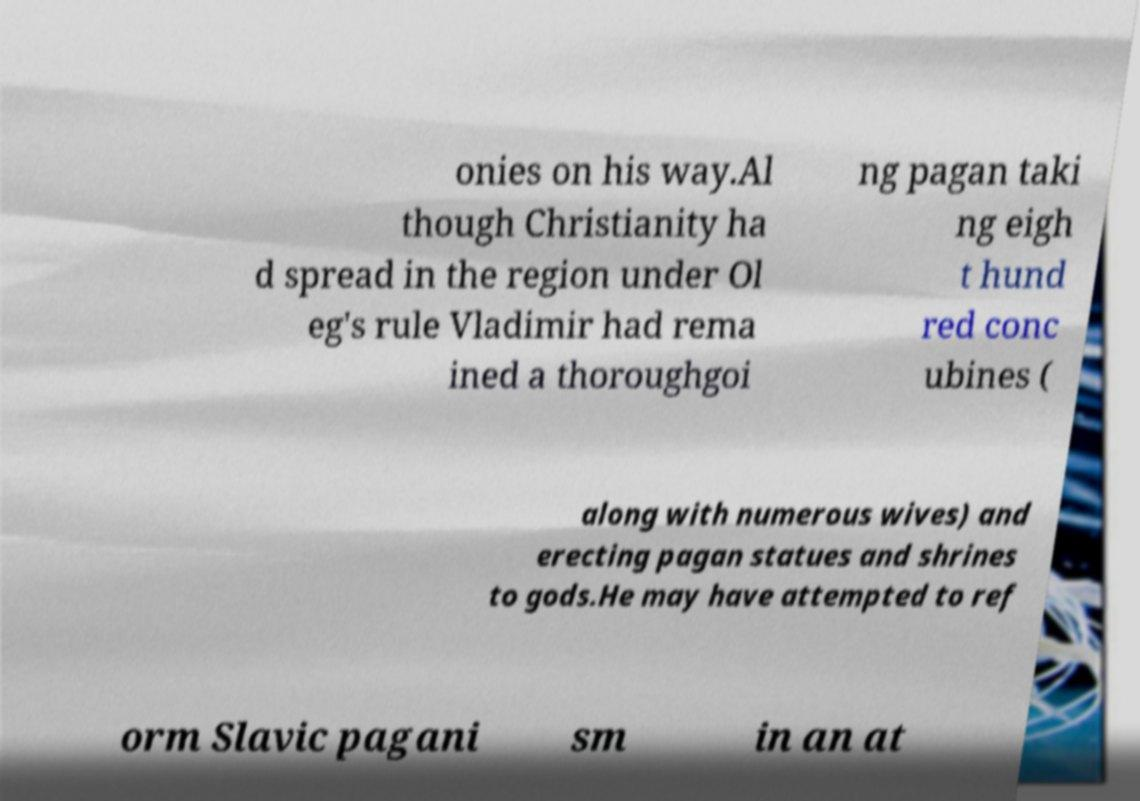For documentation purposes, I need the text within this image transcribed. Could you provide that? onies on his way.Al though Christianity ha d spread in the region under Ol eg's rule Vladimir had rema ined a thoroughgoi ng pagan taki ng eigh t hund red conc ubines ( along with numerous wives) and erecting pagan statues and shrines to gods.He may have attempted to ref orm Slavic pagani sm in an at 